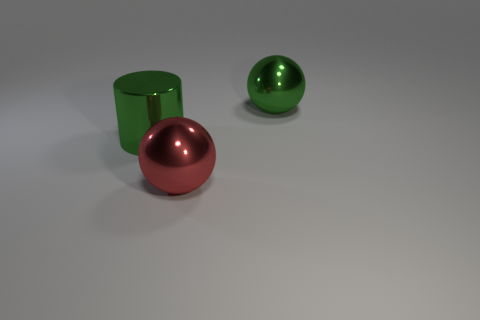What could be the purpose of these objects in a real-world setting? These objects could serve as decorative pieces due to their shiny and aesthetically pleasing appearance. The sphere could be a part of a sculptural installation, while the cylinder might function as a unique vase or container. 